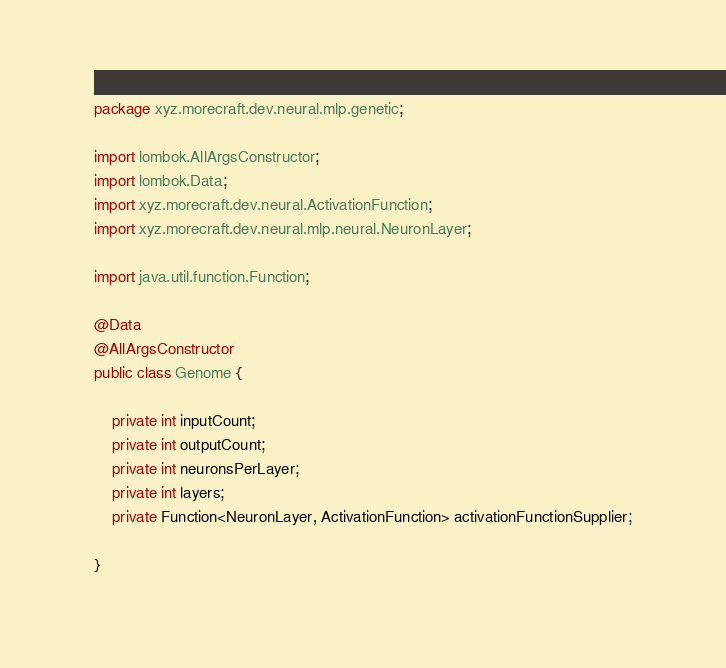<code> <loc_0><loc_0><loc_500><loc_500><_Java_>package xyz.morecraft.dev.neural.mlp.genetic;

import lombok.AllArgsConstructor;
import lombok.Data;
import xyz.morecraft.dev.neural.ActivationFunction;
import xyz.morecraft.dev.neural.mlp.neural.NeuronLayer;

import java.util.function.Function;

@Data
@AllArgsConstructor
public class Genome {

    private int inputCount;
    private int outputCount;
    private int neuronsPerLayer;
    private int layers;
    private Function<NeuronLayer, ActivationFunction> activationFunctionSupplier;

}
</code> 